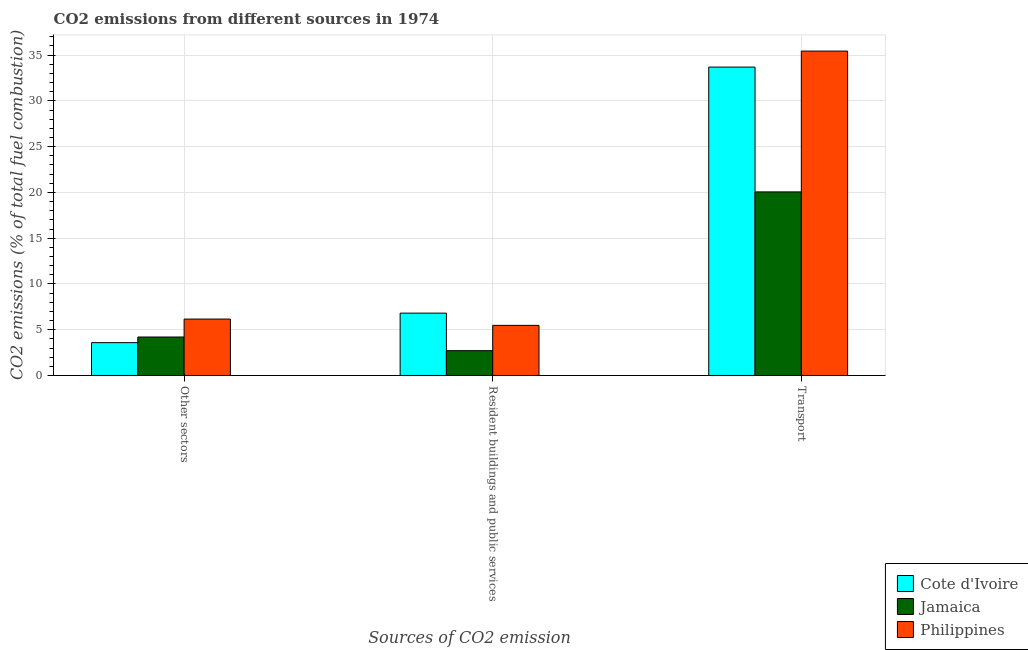Are the number of bars on each tick of the X-axis equal?
Keep it short and to the point. Yes. What is the label of the 3rd group of bars from the left?
Provide a short and direct response. Transport. What is the percentage of co2 emissions from other sectors in Cote d'Ivoire?
Provide a short and direct response. 3.58. Across all countries, what is the maximum percentage of co2 emissions from transport?
Offer a terse response. 35.44. Across all countries, what is the minimum percentage of co2 emissions from other sectors?
Offer a terse response. 3.58. In which country was the percentage of co2 emissions from resident buildings and public services maximum?
Provide a succinct answer. Cote d'Ivoire. In which country was the percentage of co2 emissions from other sectors minimum?
Provide a short and direct response. Cote d'Ivoire. What is the total percentage of co2 emissions from resident buildings and public services in the graph?
Make the answer very short. 14.99. What is the difference between the percentage of co2 emissions from resident buildings and public services in Cote d'Ivoire and that in Jamaica?
Your answer should be compact. 4.1. What is the difference between the percentage of co2 emissions from transport in Cote d'Ivoire and the percentage of co2 emissions from resident buildings and public services in Jamaica?
Make the answer very short. 30.98. What is the average percentage of co2 emissions from transport per country?
Your response must be concise. 29.73. What is the difference between the percentage of co2 emissions from resident buildings and public services and percentage of co2 emissions from other sectors in Philippines?
Give a very brief answer. -0.69. What is the ratio of the percentage of co2 emissions from other sectors in Jamaica to that in Cote d'Ivoire?
Offer a very short reply. 1.17. Is the difference between the percentage of co2 emissions from resident buildings and public services in Philippines and Jamaica greater than the difference between the percentage of co2 emissions from other sectors in Philippines and Jamaica?
Offer a terse response. Yes. What is the difference between the highest and the second highest percentage of co2 emissions from other sectors?
Give a very brief answer. 1.96. What is the difference between the highest and the lowest percentage of co2 emissions from resident buildings and public services?
Make the answer very short. 4.1. What does the 1st bar from the left in Other sectors represents?
Your response must be concise. Cote d'Ivoire. What does the 3rd bar from the right in Transport represents?
Offer a very short reply. Cote d'Ivoire. Is it the case that in every country, the sum of the percentage of co2 emissions from other sectors and percentage of co2 emissions from resident buildings and public services is greater than the percentage of co2 emissions from transport?
Offer a very short reply. No. How many countries are there in the graph?
Your answer should be very brief. 3. Does the graph contain any zero values?
Your response must be concise. No. How many legend labels are there?
Ensure brevity in your answer.  3. How are the legend labels stacked?
Keep it short and to the point. Vertical. What is the title of the graph?
Provide a succinct answer. CO2 emissions from different sources in 1974. What is the label or title of the X-axis?
Offer a terse response. Sources of CO2 emission. What is the label or title of the Y-axis?
Give a very brief answer. CO2 emissions (% of total fuel combustion). What is the CO2 emissions (% of total fuel combustion) in Cote d'Ivoire in Other sectors?
Your response must be concise. 3.58. What is the CO2 emissions (% of total fuel combustion) in Jamaica in Other sectors?
Provide a short and direct response. 4.2. What is the CO2 emissions (% of total fuel combustion) in Philippines in Other sectors?
Ensure brevity in your answer.  6.16. What is the CO2 emissions (% of total fuel combustion) in Cote d'Ivoire in Resident buildings and public services?
Provide a succinct answer. 6.81. What is the CO2 emissions (% of total fuel combustion) of Jamaica in Resident buildings and public services?
Offer a terse response. 2.71. What is the CO2 emissions (% of total fuel combustion) in Philippines in Resident buildings and public services?
Offer a terse response. 5.47. What is the CO2 emissions (% of total fuel combustion) in Cote d'Ivoire in Transport?
Provide a succinct answer. 33.69. What is the CO2 emissions (% of total fuel combustion) of Jamaica in Transport?
Make the answer very short. 20.05. What is the CO2 emissions (% of total fuel combustion) in Philippines in Transport?
Your answer should be very brief. 35.44. Across all Sources of CO2 emission, what is the maximum CO2 emissions (% of total fuel combustion) in Cote d'Ivoire?
Provide a short and direct response. 33.69. Across all Sources of CO2 emission, what is the maximum CO2 emissions (% of total fuel combustion) in Jamaica?
Provide a succinct answer. 20.05. Across all Sources of CO2 emission, what is the maximum CO2 emissions (% of total fuel combustion) in Philippines?
Provide a short and direct response. 35.44. Across all Sources of CO2 emission, what is the minimum CO2 emissions (% of total fuel combustion) of Cote d'Ivoire?
Your answer should be compact. 3.58. Across all Sources of CO2 emission, what is the minimum CO2 emissions (% of total fuel combustion) in Jamaica?
Offer a terse response. 2.71. Across all Sources of CO2 emission, what is the minimum CO2 emissions (% of total fuel combustion) in Philippines?
Offer a terse response. 5.47. What is the total CO2 emissions (% of total fuel combustion) of Cote d'Ivoire in the graph?
Provide a succinct answer. 44.09. What is the total CO2 emissions (% of total fuel combustion) of Jamaica in the graph?
Your response must be concise. 26.96. What is the total CO2 emissions (% of total fuel combustion) in Philippines in the graph?
Provide a short and direct response. 47.07. What is the difference between the CO2 emissions (% of total fuel combustion) of Cote d'Ivoire in Other sectors and that in Resident buildings and public services?
Your answer should be compact. -3.23. What is the difference between the CO2 emissions (% of total fuel combustion) of Jamaica in Other sectors and that in Resident buildings and public services?
Your response must be concise. 1.49. What is the difference between the CO2 emissions (% of total fuel combustion) of Philippines in Other sectors and that in Resident buildings and public services?
Offer a terse response. 0.69. What is the difference between the CO2 emissions (% of total fuel combustion) of Cote d'Ivoire in Other sectors and that in Transport?
Provide a short and direct response. -30.11. What is the difference between the CO2 emissions (% of total fuel combustion) in Jamaica in Other sectors and that in Transport?
Your answer should be compact. -15.85. What is the difference between the CO2 emissions (% of total fuel combustion) of Philippines in Other sectors and that in Transport?
Provide a short and direct response. -29.28. What is the difference between the CO2 emissions (% of total fuel combustion) in Cote d'Ivoire in Resident buildings and public services and that in Transport?
Keep it short and to the point. -26.88. What is the difference between the CO2 emissions (% of total fuel combustion) of Jamaica in Resident buildings and public services and that in Transport?
Provide a short and direct response. -17.34. What is the difference between the CO2 emissions (% of total fuel combustion) in Philippines in Resident buildings and public services and that in Transport?
Make the answer very short. -29.97. What is the difference between the CO2 emissions (% of total fuel combustion) in Cote d'Ivoire in Other sectors and the CO2 emissions (% of total fuel combustion) in Jamaica in Resident buildings and public services?
Your response must be concise. 0.87. What is the difference between the CO2 emissions (% of total fuel combustion) of Cote d'Ivoire in Other sectors and the CO2 emissions (% of total fuel combustion) of Philippines in Resident buildings and public services?
Provide a short and direct response. -1.89. What is the difference between the CO2 emissions (% of total fuel combustion) of Jamaica in Other sectors and the CO2 emissions (% of total fuel combustion) of Philippines in Resident buildings and public services?
Your answer should be compact. -1.27. What is the difference between the CO2 emissions (% of total fuel combustion) of Cote d'Ivoire in Other sectors and the CO2 emissions (% of total fuel combustion) of Jamaica in Transport?
Your response must be concise. -16.47. What is the difference between the CO2 emissions (% of total fuel combustion) in Cote d'Ivoire in Other sectors and the CO2 emissions (% of total fuel combustion) in Philippines in Transport?
Make the answer very short. -31.85. What is the difference between the CO2 emissions (% of total fuel combustion) in Jamaica in Other sectors and the CO2 emissions (% of total fuel combustion) in Philippines in Transport?
Make the answer very short. -31.24. What is the difference between the CO2 emissions (% of total fuel combustion) of Cote d'Ivoire in Resident buildings and public services and the CO2 emissions (% of total fuel combustion) of Jamaica in Transport?
Provide a succinct answer. -13.24. What is the difference between the CO2 emissions (% of total fuel combustion) in Cote d'Ivoire in Resident buildings and public services and the CO2 emissions (% of total fuel combustion) in Philippines in Transport?
Your answer should be compact. -28.63. What is the difference between the CO2 emissions (% of total fuel combustion) in Jamaica in Resident buildings and public services and the CO2 emissions (% of total fuel combustion) in Philippines in Transport?
Offer a very short reply. -32.73. What is the average CO2 emissions (% of total fuel combustion) of Cote d'Ivoire per Sources of CO2 emission?
Your answer should be very brief. 14.7. What is the average CO2 emissions (% of total fuel combustion) in Jamaica per Sources of CO2 emission?
Your answer should be very brief. 8.99. What is the average CO2 emissions (% of total fuel combustion) in Philippines per Sources of CO2 emission?
Give a very brief answer. 15.69. What is the difference between the CO2 emissions (% of total fuel combustion) in Cote d'Ivoire and CO2 emissions (% of total fuel combustion) in Jamaica in Other sectors?
Give a very brief answer. -0.62. What is the difference between the CO2 emissions (% of total fuel combustion) of Cote d'Ivoire and CO2 emissions (% of total fuel combustion) of Philippines in Other sectors?
Provide a succinct answer. -2.58. What is the difference between the CO2 emissions (% of total fuel combustion) of Jamaica and CO2 emissions (% of total fuel combustion) of Philippines in Other sectors?
Keep it short and to the point. -1.96. What is the difference between the CO2 emissions (% of total fuel combustion) of Cote d'Ivoire and CO2 emissions (% of total fuel combustion) of Philippines in Resident buildings and public services?
Provide a succinct answer. 1.34. What is the difference between the CO2 emissions (% of total fuel combustion) of Jamaica and CO2 emissions (% of total fuel combustion) of Philippines in Resident buildings and public services?
Give a very brief answer. -2.76. What is the difference between the CO2 emissions (% of total fuel combustion) of Cote d'Ivoire and CO2 emissions (% of total fuel combustion) of Jamaica in Transport?
Your answer should be compact. 13.64. What is the difference between the CO2 emissions (% of total fuel combustion) of Cote d'Ivoire and CO2 emissions (% of total fuel combustion) of Philippines in Transport?
Your response must be concise. -1.75. What is the difference between the CO2 emissions (% of total fuel combustion) in Jamaica and CO2 emissions (% of total fuel combustion) in Philippines in Transport?
Provide a short and direct response. -15.38. What is the ratio of the CO2 emissions (% of total fuel combustion) of Cote d'Ivoire in Other sectors to that in Resident buildings and public services?
Give a very brief answer. 0.53. What is the ratio of the CO2 emissions (% of total fuel combustion) of Jamaica in Other sectors to that in Resident buildings and public services?
Keep it short and to the point. 1.55. What is the ratio of the CO2 emissions (% of total fuel combustion) of Philippines in Other sectors to that in Resident buildings and public services?
Your answer should be compact. 1.13. What is the ratio of the CO2 emissions (% of total fuel combustion) in Cote d'Ivoire in Other sectors to that in Transport?
Your answer should be compact. 0.11. What is the ratio of the CO2 emissions (% of total fuel combustion) in Jamaica in Other sectors to that in Transport?
Keep it short and to the point. 0.21. What is the ratio of the CO2 emissions (% of total fuel combustion) in Philippines in Other sectors to that in Transport?
Provide a succinct answer. 0.17. What is the ratio of the CO2 emissions (% of total fuel combustion) in Cote d'Ivoire in Resident buildings and public services to that in Transport?
Make the answer very short. 0.2. What is the ratio of the CO2 emissions (% of total fuel combustion) of Jamaica in Resident buildings and public services to that in Transport?
Keep it short and to the point. 0.14. What is the ratio of the CO2 emissions (% of total fuel combustion) in Philippines in Resident buildings and public services to that in Transport?
Keep it short and to the point. 0.15. What is the difference between the highest and the second highest CO2 emissions (% of total fuel combustion) in Cote d'Ivoire?
Provide a succinct answer. 26.88. What is the difference between the highest and the second highest CO2 emissions (% of total fuel combustion) of Jamaica?
Your response must be concise. 15.85. What is the difference between the highest and the second highest CO2 emissions (% of total fuel combustion) of Philippines?
Your response must be concise. 29.28. What is the difference between the highest and the lowest CO2 emissions (% of total fuel combustion) of Cote d'Ivoire?
Keep it short and to the point. 30.11. What is the difference between the highest and the lowest CO2 emissions (% of total fuel combustion) in Jamaica?
Your answer should be very brief. 17.34. What is the difference between the highest and the lowest CO2 emissions (% of total fuel combustion) in Philippines?
Make the answer very short. 29.97. 